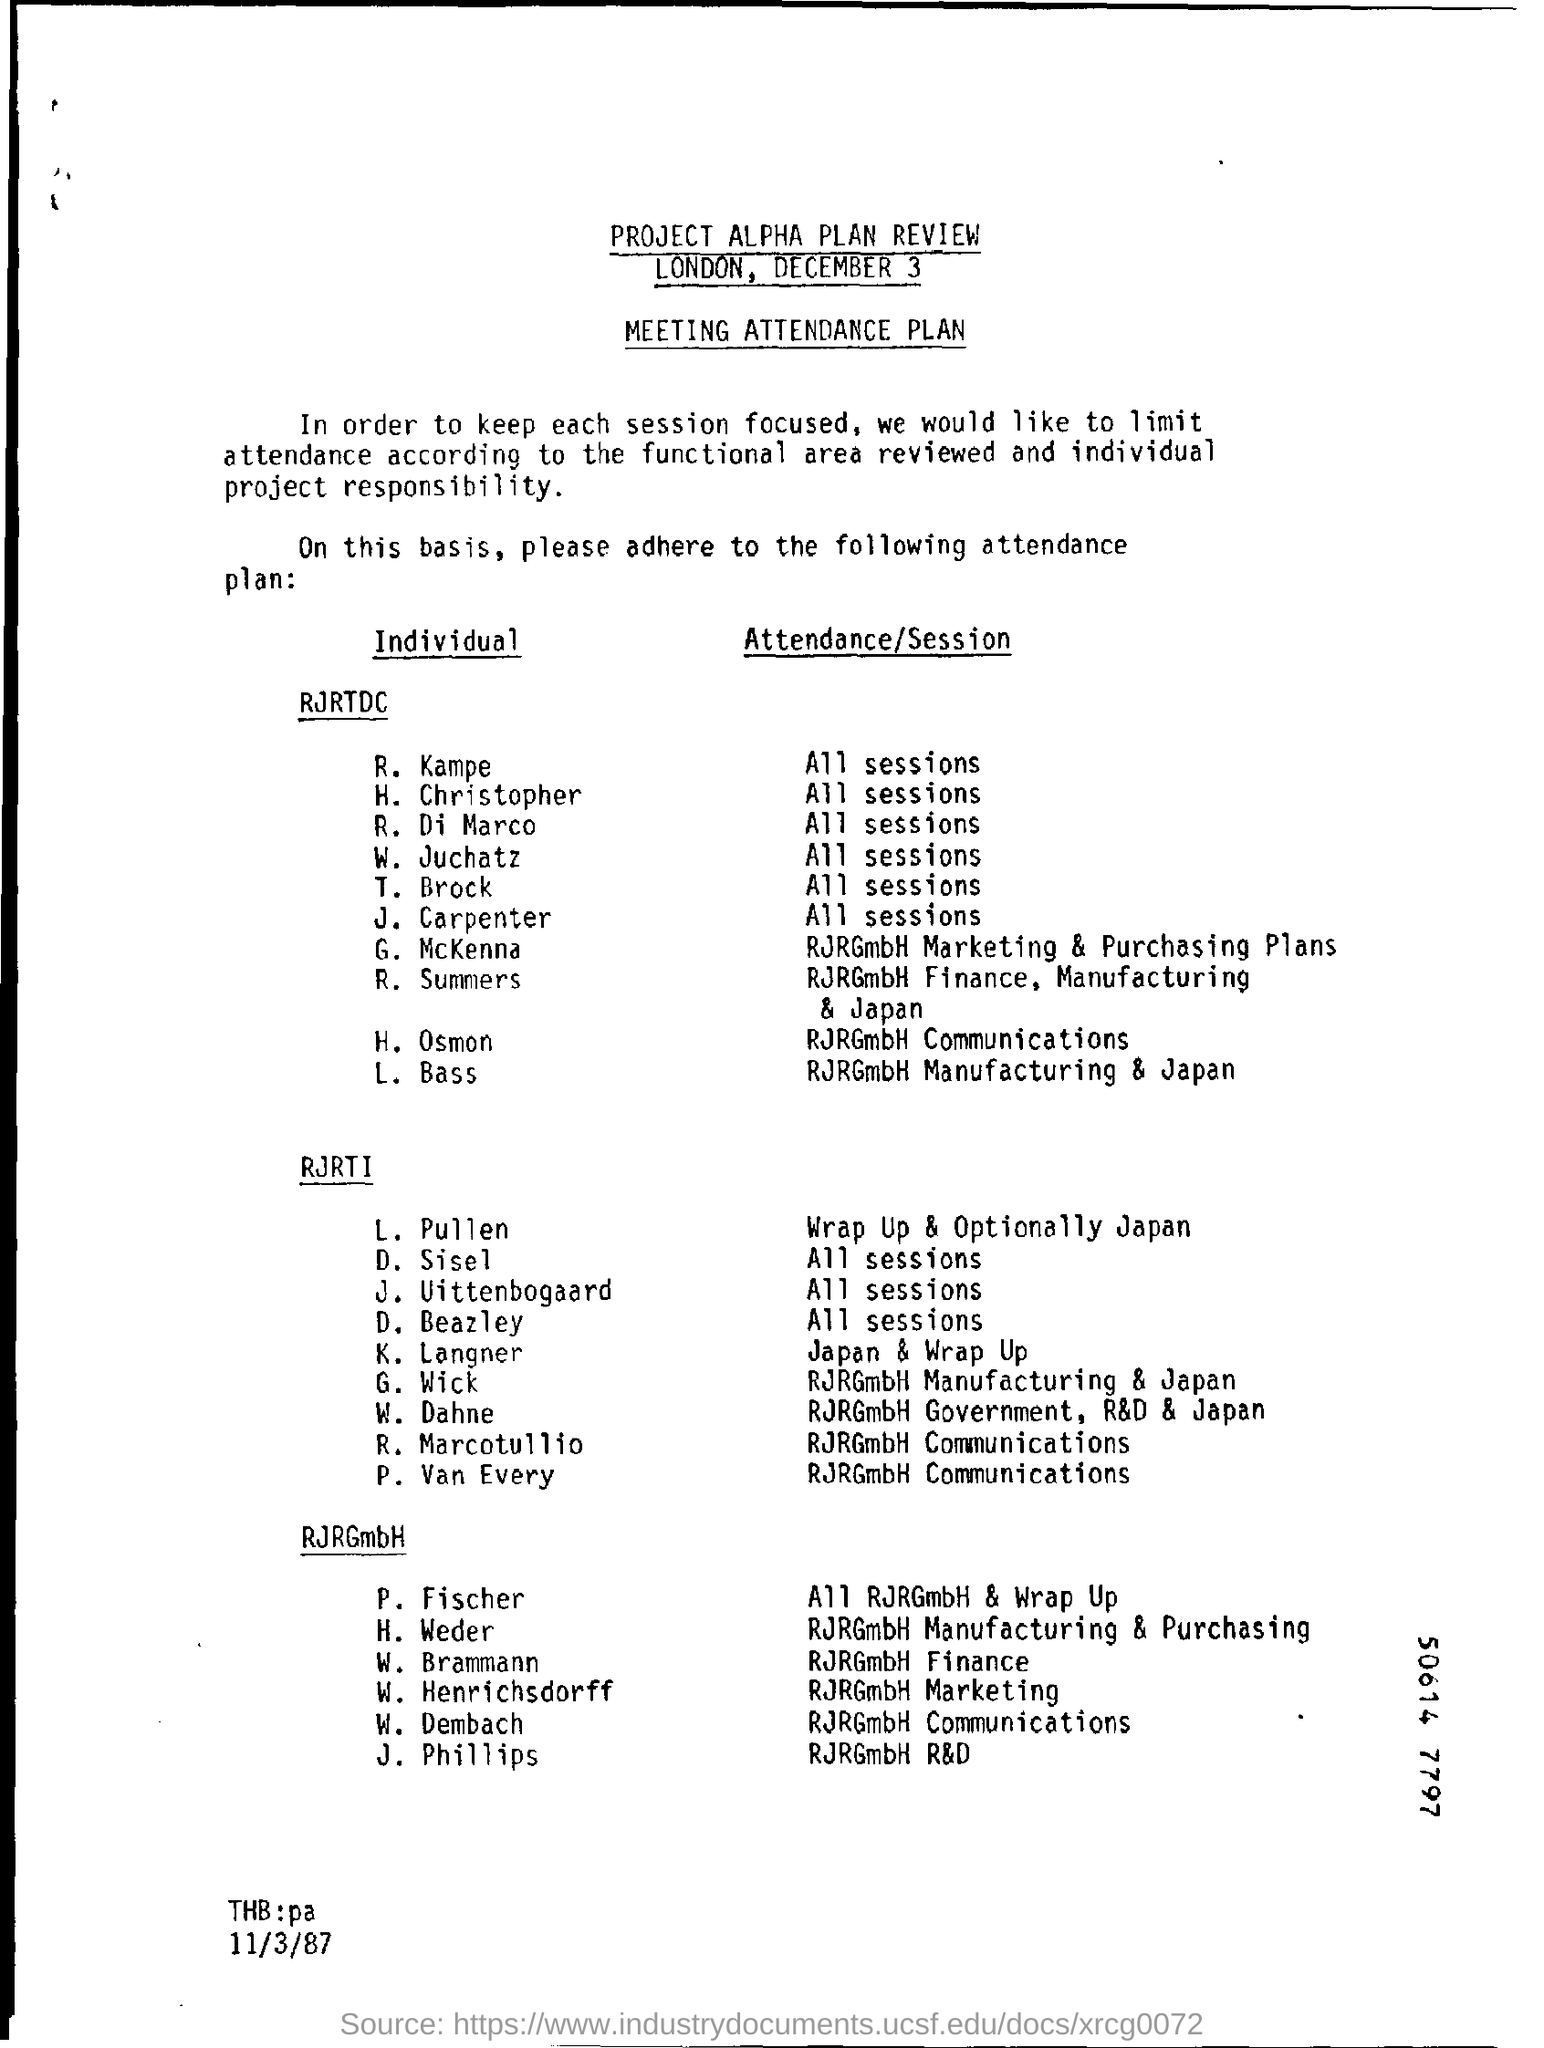Who attended the RJRRGmbH Finance Manufacturing  & Japan session of RJRTDC?
Ensure brevity in your answer.  R. Summers. 